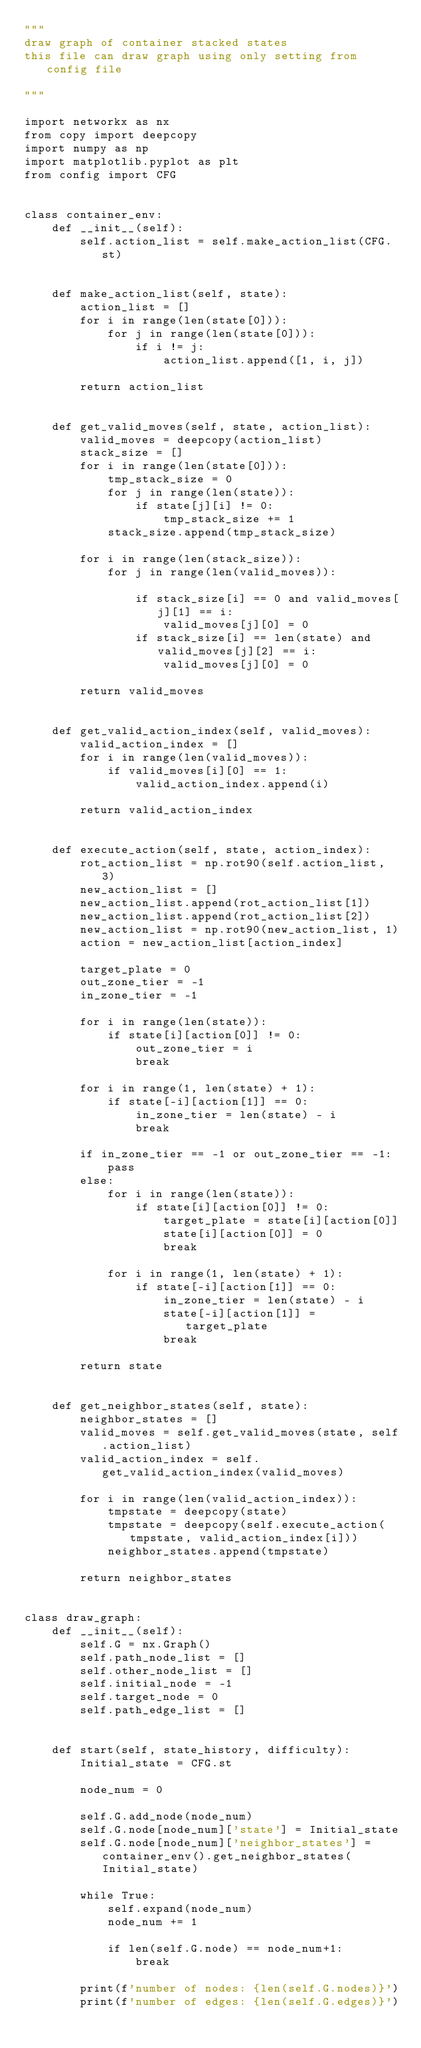<code> <loc_0><loc_0><loc_500><loc_500><_Python_>"""
draw graph of container stacked states
this file can draw graph using only setting from config file

"""

import networkx as nx
from copy import deepcopy
import numpy as np
import matplotlib.pyplot as plt
from config import CFG


class container_env:
    def __init__(self):
        self.action_list = self.make_action_list(CFG.st)


    def make_action_list(self, state):
        action_list = []
        for i in range(len(state[0])):
            for j in range(len(state[0])):
                if i != j:
                    action_list.append([1, i, j])

        return action_list


    def get_valid_moves(self, state, action_list):
        valid_moves = deepcopy(action_list)
        stack_size = []
        for i in range(len(state[0])):
            tmp_stack_size = 0
            for j in range(len(state)):
                if state[j][i] != 0:
                    tmp_stack_size += 1
            stack_size.append(tmp_stack_size)

        for i in range(len(stack_size)):
            for j in range(len(valid_moves)):

                if stack_size[i] == 0 and valid_moves[j][1] == i:
                    valid_moves[j][0] = 0
                if stack_size[i] == len(state) and valid_moves[j][2] == i:
                    valid_moves[j][0] = 0

        return valid_moves


    def get_valid_action_index(self, valid_moves):
        valid_action_index = []
        for i in range(len(valid_moves)):
            if valid_moves[i][0] == 1:
                valid_action_index.append(i)

        return valid_action_index


    def execute_action(self, state, action_index):
        rot_action_list = np.rot90(self.action_list, 3)
        new_action_list = []
        new_action_list.append(rot_action_list[1])
        new_action_list.append(rot_action_list[2])
        new_action_list = np.rot90(new_action_list, 1)
        action = new_action_list[action_index]

        target_plate = 0
        out_zone_tier = -1
        in_zone_tier = -1

        for i in range(len(state)):
            if state[i][action[0]] != 0:
                out_zone_tier = i
                break

        for i in range(1, len(state) + 1):
            if state[-i][action[1]] == 0:
                in_zone_tier = len(state) - i
                break

        if in_zone_tier == -1 or out_zone_tier == -1:
            pass
        else:
            for i in range(len(state)):
                if state[i][action[0]] != 0:
                    target_plate = state[i][action[0]]
                    state[i][action[0]] = 0
                    break

            for i in range(1, len(state) + 1):
                if state[-i][action[1]] == 0:
                    in_zone_tier = len(state) - i
                    state[-i][action[1]] = target_plate
                    break

        return state


    def get_neighbor_states(self, state):
        neighbor_states = []
        valid_moves = self.get_valid_moves(state, self.action_list)
        valid_action_index = self.get_valid_action_index(valid_moves)

        for i in range(len(valid_action_index)):
            tmpstate = deepcopy(state)
            tmpstate = deepcopy(self.execute_action(tmpstate, valid_action_index[i]))
            neighbor_states.append(tmpstate)

        return neighbor_states


class draw_graph:
    def __init__(self):
        self.G = nx.Graph()
        self.path_node_list = []
        self.other_node_list = []
        self.initial_node = -1
        self.target_node = 0
        self.path_edge_list = []


    def start(self, state_history, difficulty):
        Initial_state = CFG.st

        node_num = 0

        self.G.add_node(node_num)
        self.G.node[node_num]['state'] = Initial_state
        self.G.node[node_num]['neighbor_states'] = container_env().get_neighbor_states(Initial_state)

        while True:
            self.expand(node_num)
            node_num += 1

            if len(self.G.node) == node_num+1:
                break

        print(f'number of nodes: {len(self.G.nodes)}')
        print(f'number of edges: {len(self.G.edges)}')
</code> 